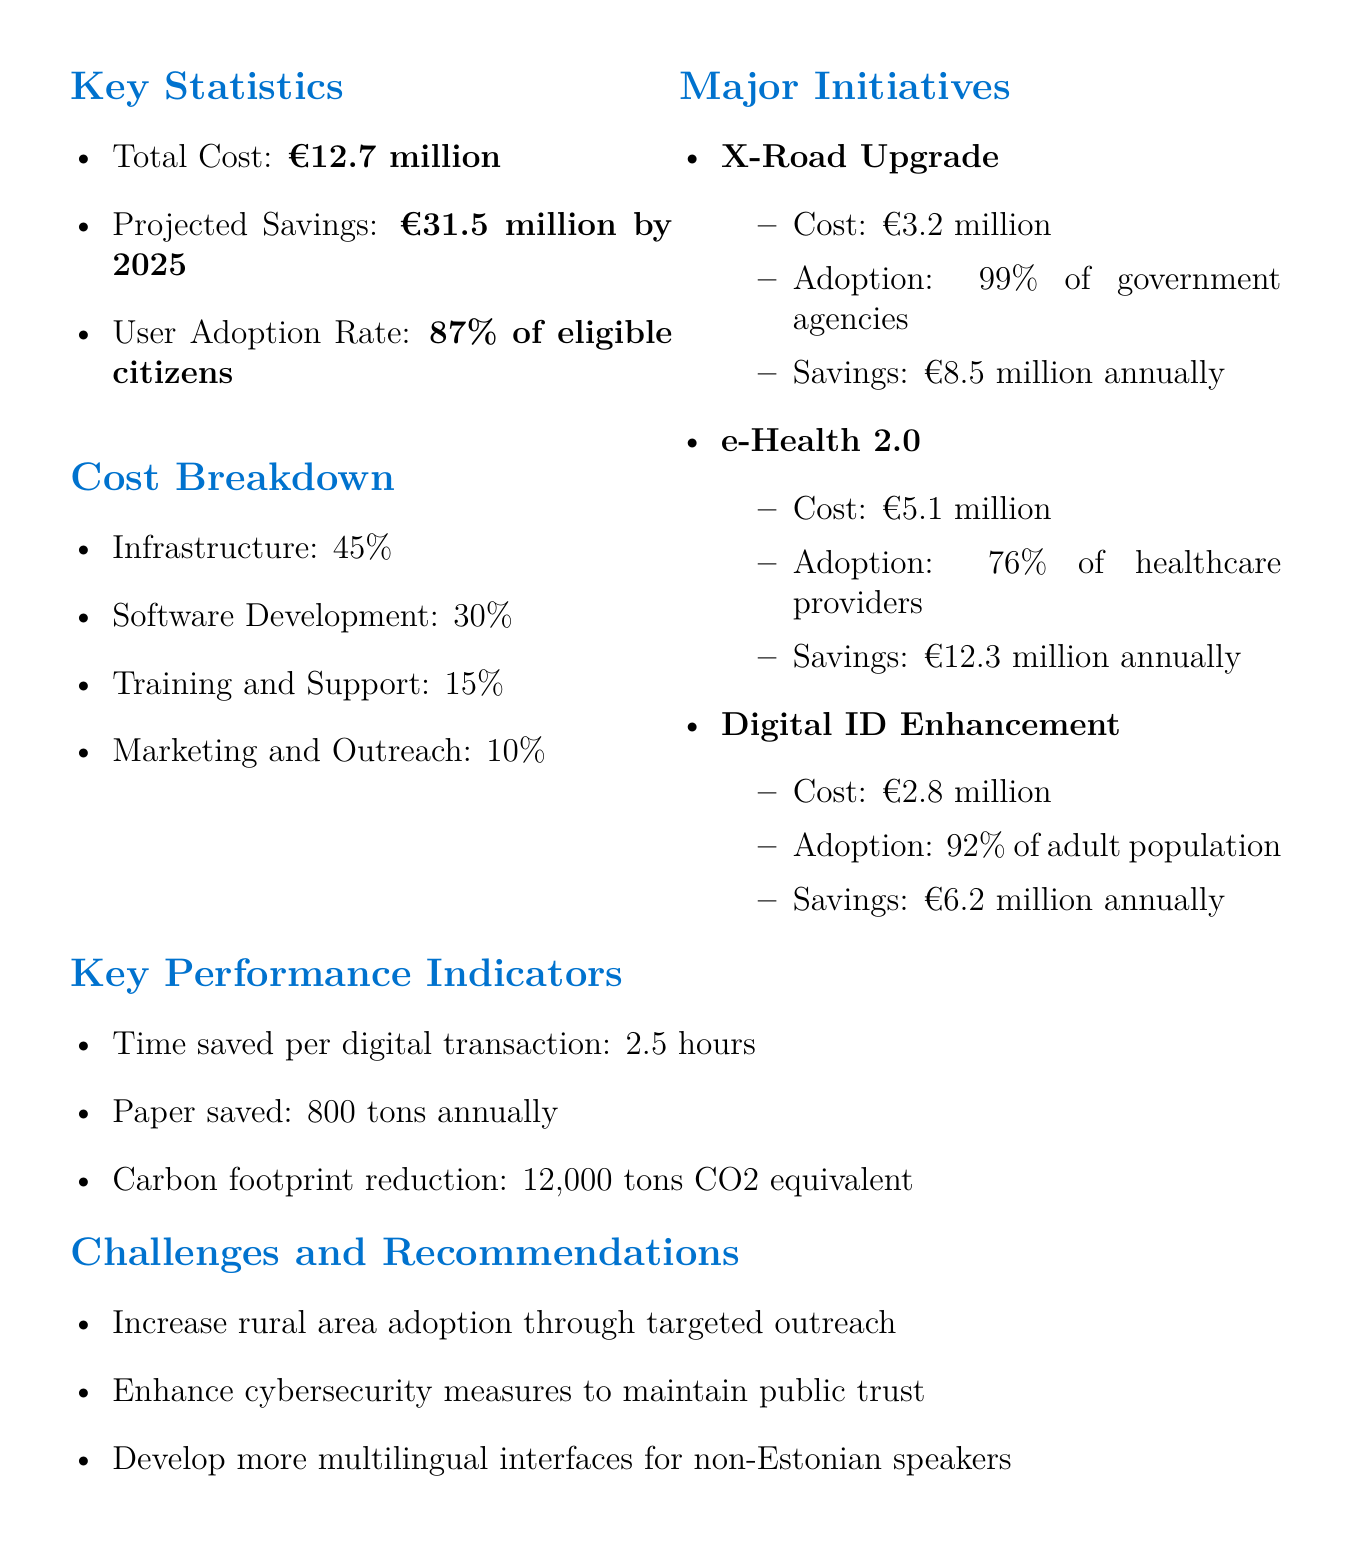What is the total cost of e-governance initiatives? The total cost is explicitly stated in the document as €12.7 million.
Answer: €12.7 million What is the projected savings by 2025? The projected savings by 2025 is specified in the report as €31.5 million.
Answer: €31.5 million What is the user adoption rate among eligible citizens? The document reports that 87% of eligible citizens are adopting the e-governance initiatives.
Answer: 87% of eligible citizens How much does the X-Road Upgrade cost? The cost associated with the X-Road Upgrade initiative is detailed as €3.2 million.
Answer: €3.2 million What percentage of government agencies have adopted the X-Road Upgrade? The adoption rate of the X-Road Upgrade by government agencies is stated as 99%.
Answer: 99% What is the annual savings projected from e-Health 2.0? The document specifies that e-Health 2.0 is expected to save €12.3 million annually.
Answer: €12.3 million annually What challenge is recommended for improving rural area adoption? The document suggests targeted outreach to increase rural area adoption.
Answer: Targeted outreach What is a key performance indicator regarding paper usage? The report mentions that 800 tons of paper are saved annually.
Answer: 800 tons annually What is the main focus of the challenges and recommendations section? The section primarily focuses on improving adoption and cybersecurity measures.
Answer: Improving adoption and cybersecurity measures 